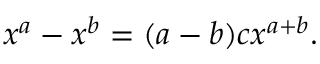<formula> <loc_0><loc_0><loc_500><loc_500>x ^ { a } - x ^ { b } = ( a - b ) c x ^ { a + b } .</formula> 